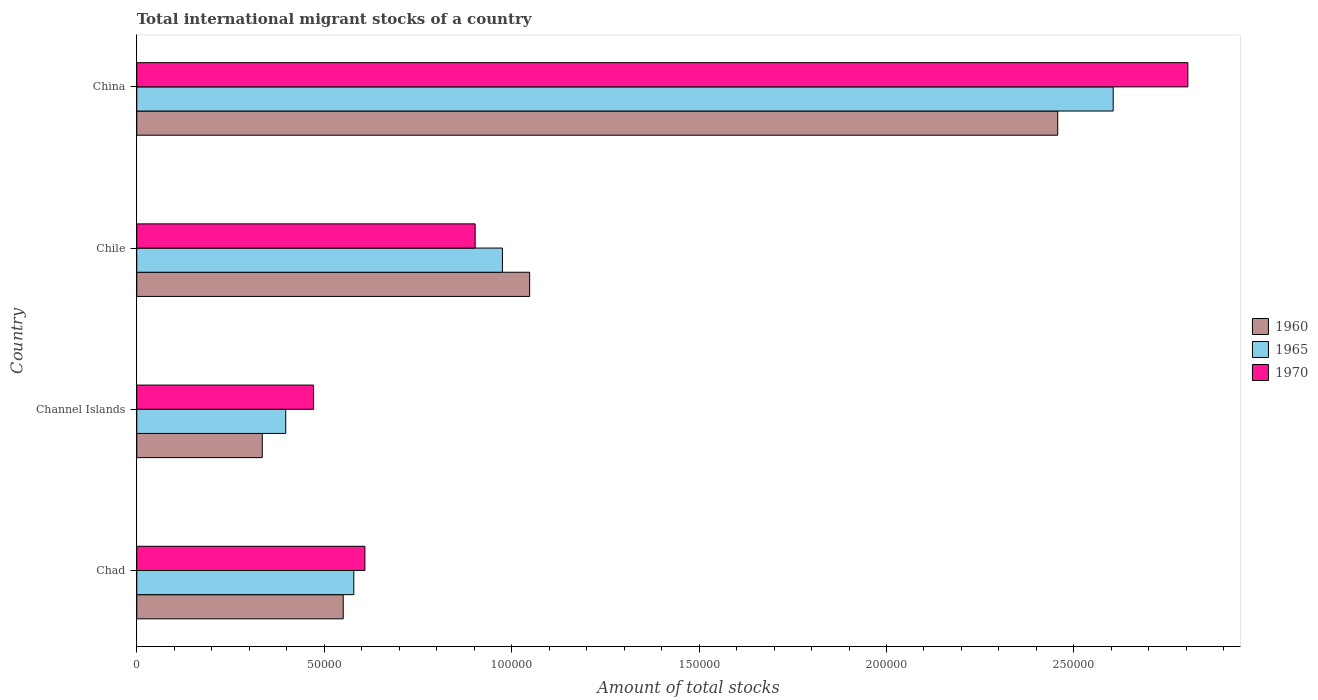How many different coloured bars are there?
Your response must be concise. 3. Are the number of bars per tick equal to the number of legend labels?
Your answer should be very brief. Yes. Are the number of bars on each tick of the Y-axis equal?
Your answer should be very brief. Yes. What is the amount of total stocks in in 1970 in Chad?
Offer a very short reply. 6.09e+04. Across all countries, what is the maximum amount of total stocks in in 1960?
Keep it short and to the point. 2.46e+05. Across all countries, what is the minimum amount of total stocks in in 1965?
Your answer should be compact. 3.97e+04. In which country was the amount of total stocks in in 1965 minimum?
Offer a very short reply. Channel Islands. What is the total amount of total stocks in in 1960 in the graph?
Your answer should be compact. 4.39e+05. What is the difference between the amount of total stocks in in 1960 in Chad and that in Channel Islands?
Provide a succinct answer. 2.16e+04. What is the difference between the amount of total stocks in in 1965 in China and the amount of total stocks in in 1970 in Chad?
Keep it short and to the point. 2.00e+05. What is the average amount of total stocks in in 1970 per country?
Offer a terse response. 1.20e+05. What is the difference between the amount of total stocks in in 1970 and amount of total stocks in in 1960 in China?
Your answer should be compact. 3.47e+04. What is the ratio of the amount of total stocks in in 1965 in Chad to that in Chile?
Provide a short and direct response. 0.59. Is the amount of total stocks in in 1960 in Channel Islands less than that in China?
Provide a succinct answer. Yes. What is the difference between the highest and the second highest amount of total stocks in in 1965?
Make the answer very short. 1.63e+05. What is the difference between the highest and the lowest amount of total stocks in in 1960?
Offer a very short reply. 2.12e+05. Is the sum of the amount of total stocks in in 1960 in Chad and Channel Islands greater than the maximum amount of total stocks in in 1970 across all countries?
Offer a very short reply. No. What does the 2nd bar from the top in China represents?
Your response must be concise. 1965. What does the 1st bar from the bottom in China represents?
Give a very brief answer. 1960. Is it the case that in every country, the sum of the amount of total stocks in in 1970 and amount of total stocks in in 1965 is greater than the amount of total stocks in in 1960?
Ensure brevity in your answer.  Yes. Are all the bars in the graph horizontal?
Your answer should be compact. Yes. How many countries are there in the graph?
Offer a very short reply. 4. What is the difference between two consecutive major ticks on the X-axis?
Offer a very short reply. 5.00e+04. Are the values on the major ticks of X-axis written in scientific E-notation?
Offer a very short reply. No. Does the graph contain any zero values?
Offer a very short reply. No. Does the graph contain grids?
Ensure brevity in your answer.  No. How many legend labels are there?
Provide a succinct answer. 3. How are the legend labels stacked?
Make the answer very short. Vertical. What is the title of the graph?
Provide a succinct answer. Total international migrant stocks of a country. What is the label or title of the X-axis?
Your answer should be compact. Amount of total stocks. What is the label or title of the Y-axis?
Offer a terse response. Country. What is the Amount of total stocks in 1960 in Chad?
Keep it short and to the point. 5.51e+04. What is the Amount of total stocks of 1965 in Chad?
Ensure brevity in your answer.  5.79e+04. What is the Amount of total stocks of 1970 in Chad?
Your response must be concise. 6.09e+04. What is the Amount of total stocks in 1960 in Channel Islands?
Provide a succinct answer. 3.35e+04. What is the Amount of total stocks in 1965 in Channel Islands?
Provide a short and direct response. 3.97e+04. What is the Amount of total stocks of 1970 in Channel Islands?
Provide a short and direct response. 4.72e+04. What is the Amount of total stocks of 1960 in Chile?
Provide a succinct answer. 1.05e+05. What is the Amount of total stocks of 1965 in Chile?
Your response must be concise. 9.76e+04. What is the Amount of total stocks of 1970 in Chile?
Your answer should be very brief. 9.03e+04. What is the Amount of total stocks of 1960 in China?
Ensure brevity in your answer.  2.46e+05. What is the Amount of total stocks of 1965 in China?
Provide a succinct answer. 2.60e+05. What is the Amount of total stocks of 1970 in China?
Offer a terse response. 2.80e+05. Across all countries, what is the maximum Amount of total stocks in 1960?
Provide a short and direct response. 2.46e+05. Across all countries, what is the maximum Amount of total stocks in 1965?
Provide a succinct answer. 2.60e+05. Across all countries, what is the maximum Amount of total stocks in 1970?
Provide a short and direct response. 2.80e+05. Across all countries, what is the minimum Amount of total stocks in 1960?
Provide a short and direct response. 3.35e+04. Across all countries, what is the minimum Amount of total stocks in 1965?
Keep it short and to the point. 3.97e+04. Across all countries, what is the minimum Amount of total stocks in 1970?
Keep it short and to the point. 4.72e+04. What is the total Amount of total stocks in 1960 in the graph?
Your answer should be compact. 4.39e+05. What is the total Amount of total stocks of 1965 in the graph?
Offer a terse response. 4.56e+05. What is the total Amount of total stocks in 1970 in the graph?
Your answer should be very brief. 4.79e+05. What is the difference between the Amount of total stocks in 1960 in Chad and that in Channel Islands?
Your answer should be compact. 2.16e+04. What is the difference between the Amount of total stocks of 1965 in Chad and that in Channel Islands?
Provide a succinct answer. 1.82e+04. What is the difference between the Amount of total stocks in 1970 in Chad and that in Channel Islands?
Your response must be concise. 1.37e+04. What is the difference between the Amount of total stocks in 1960 in Chad and that in Chile?
Provide a succinct answer. -4.97e+04. What is the difference between the Amount of total stocks of 1965 in Chad and that in Chile?
Give a very brief answer. -3.97e+04. What is the difference between the Amount of total stocks of 1970 in Chad and that in Chile?
Offer a very short reply. -2.94e+04. What is the difference between the Amount of total stocks of 1960 in Chad and that in China?
Give a very brief answer. -1.91e+05. What is the difference between the Amount of total stocks of 1965 in Chad and that in China?
Ensure brevity in your answer.  -2.03e+05. What is the difference between the Amount of total stocks in 1970 in Chad and that in China?
Your response must be concise. -2.20e+05. What is the difference between the Amount of total stocks of 1960 in Channel Islands and that in Chile?
Offer a terse response. -7.13e+04. What is the difference between the Amount of total stocks in 1965 in Channel Islands and that in Chile?
Your answer should be compact. -5.78e+04. What is the difference between the Amount of total stocks of 1970 in Channel Islands and that in Chile?
Keep it short and to the point. -4.31e+04. What is the difference between the Amount of total stocks in 1960 in Channel Islands and that in China?
Make the answer very short. -2.12e+05. What is the difference between the Amount of total stocks in 1965 in Channel Islands and that in China?
Ensure brevity in your answer.  -2.21e+05. What is the difference between the Amount of total stocks of 1970 in Channel Islands and that in China?
Offer a very short reply. -2.33e+05. What is the difference between the Amount of total stocks in 1960 in Chile and that in China?
Ensure brevity in your answer.  -1.41e+05. What is the difference between the Amount of total stocks in 1965 in Chile and that in China?
Provide a short and direct response. -1.63e+05. What is the difference between the Amount of total stocks in 1970 in Chile and that in China?
Give a very brief answer. -1.90e+05. What is the difference between the Amount of total stocks of 1960 in Chad and the Amount of total stocks of 1965 in Channel Islands?
Make the answer very short. 1.53e+04. What is the difference between the Amount of total stocks of 1960 in Chad and the Amount of total stocks of 1970 in Channel Islands?
Provide a short and direct response. 7907. What is the difference between the Amount of total stocks of 1965 in Chad and the Amount of total stocks of 1970 in Channel Islands?
Your answer should be compact. 1.07e+04. What is the difference between the Amount of total stocks in 1960 in Chad and the Amount of total stocks in 1965 in Chile?
Ensure brevity in your answer.  -4.25e+04. What is the difference between the Amount of total stocks in 1960 in Chad and the Amount of total stocks in 1970 in Chile?
Your answer should be compact. -3.52e+04. What is the difference between the Amount of total stocks in 1965 in Chad and the Amount of total stocks in 1970 in Chile?
Provide a succinct answer. -3.24e+04. What is the difference between the Amount of total stocks in 1960 in Chad and the Amount of total stocks in 1965 in China?
Your answer should be compact. -2.05e+05. What is the difference between the Amount of total stocks in 1960 in Chad and the Amount of total stocks in 1970 in China?
Your response must be concise. -2.25e+05. What is the difference between the Amount of total stocks in 1965 in Chad and the Amount of total stocks in 1970 in China?
Ensure brevity in your answer.  -2.23e+05. What is the difference between the Amount of total stocks in 1960 in Channel Islands and the Amount of total stocks in 1965 in Chile?
Your answer should be compact. -6.41e+04. What is the difference between the Amount of total stocks of 1960 in Channel Islands and the Amount of total stocks of 1970 in Chile?
Offer a very short reply. -5.68e+04. What is the difference between the Amount of total stocks of 1965 in Channel Islands and the Amount of total stocks of 1970 in Chile?
Your answer should be very brief. -5.05e+04. What is the difference between the Amount of total stocks in 1960 in Channel Islands and the Amount of total stocks in 1965 in China?
Offer a terse response. -2.27e+05. What is the difference between the Amount of total stocks in 1960 in Channel Islands and the Amount of total stocks in 1970 in China?
Give a very brief answer. -2.47e+05. What is the difference between the Amount of total stocks in 1965 in Channel Islands and the Amount of total stocks in 1970 in China?
Your answer should be compact. -2.41e+05. What is the difference between the Amount of total stocks of 1960 in Chile and the Amount of total stocks of 1965 in China?
Offer a terse response. -1.56e+05. What is the difference between the Amount of total stocks in 1960 in Chile and the Amount of total stocks in 1970 in China?
Offer a very short reply. -1.76e+05. What is the difference between the Amount of total stocks of 1965 in Chile and the Amount of total stocks of 1970 in China?
Give a very brief answer. -1.83e+05. What is the average Amount of total stocks of 1960 per country?
Your answer should be very brief. 1.10e+05. What is the average Amount of total stocks of 1965 per country?
Provide a succinct answer. 1.14e+05. What is the average Amount of total stocks in 1970 per country?
Your response must be concise. 1.20e+05. What is the difference between the Amount of total stocks in 1960 and Amount of total stocks in 1965 in Chad?
Your answer should be very brief. -2824. What is the difference between the Amount of total stocks of 1960 and Amount of total stocks of 1970 in Chad?
Your answer should be very brief. -5793. What is the difference between the Amount of total stocks in 1965 and Amount of total stocks in 1970 in Chad?
Give a very brief answer. -2969. What is the difference between the Amount of total stocks of 1960 and Amount of total stocks of 1965 in Channel Islands?
Your answer should be compact. -6257. What is the difference between the Amount of total stocks in 1960 and Amount of total stocks in 1970 in Channel Islands?
Make the answer very short. -1.37e+04. What is the difference between the Amount of total stocks in 1965 and Amount of total stocks in 1970 in Channel Islands?
Your response must be concise. -7426. What is the difference between the Amount of total stocks in 1960 and Amount of total stocks in 1965 in Chile?
Your answer should be very brief. 7254. What is the difference between the Amount of total stocks in 1960 and Amount of total stocks in 1970 in Chile?
Ensure brevity in your answer.  1.45e+04. What is the difference between the Amount of total stocks of 1965 and Amount of total stocks of 1970 in Chile?
Provide a succinct answer. 7280. What is the difference between the Amount of total stocks of 1960 and Amount of total stocks of 1965 in China?
Provide a short and direct response. -1.48e+04. What is the difference between the Amount of total stocks in 1960 and Amount of total stocks in 1970 in China?
Keep it short and to the point. -3.47e+04. What is the difference between the Amount of total stocks in 1965 and Amount of total stocks in 1970 in China?
Your answer should be very brief. -1.99e+04. What is the ratio of the Amount of total stocks of 1960 in Chad to that in Channel Islands?
Offer a terse response. 1.64. What is the ratio of the Amount of total stocks in 1965 in Chad to that in Channel Islands?
Offer a terse response. 1.46. What is the ratio of the Amount of total stocks of 1970 in Chad to that in Channel Islands?
Offer a very short reply. 1.29. What is the ratio of the Amount of total stocks in 1960 in Chad to that in Chile?
Give a very brief answer. 0.53. What is the ratio of the Amount of total stocks of 1965 in Chad to that in Chile?
Your response must be concise. 0.59. What is the ratio of the Amount of total stocks of 1970 in Chad to that in Chile?
Your response must be concise. 0.67. What is the ratio of the Amount of total stocks in 1960 in Chad to that in China?
Give a very brief answer. 0.22. What is the ratio of the Amount of total stocks in 1965 in Chad to that in China?
Your response must be concise. 0.22. What is the ratio of the Amount of total stocks in 1970 in Chad to that in China?
Your answer should be compact. 0.22. What is the ratio of the Amount of total stocks in 1960 in Channel Islands to that in Chile?
Keep it short and to the point. 0.32. What is the ratio of the Amount of total stocks in 1965 in Channel Islands to that in Chile?
Your response must be concise. 0.41. What is the ratio of the Amount of total stocks in 1970 in Channel Islands to that in Chile?
Your answer should be compact. 0.52. What is the ratio of the Amount of total stocks in 1960 in Channel Islands to that in China?
Provide a succinct answer. 0.14. What is the ratio of the Amount of total stocks in 1965 in Channel Islands to that in China?
Provide a succinct answer. 0.15. What is the ratio of the Amount of total stocks in 1970 in Channel Islands to that in China?
Give a very brief answer. 0.17. What is the ratio of the Amount of total stocks in 1960 in Chile to that in China?
Make the answer very short. 0.43. What is the ratio of the Amount of total stocks of 1965 in Chile to that in China?
Keep it short and to the point. 0.37. What is the ratio of the Amount of total stocks of 1970 in Chile to that in China?
Offer a terse response. 0.32. What is the difference between the highest and the second highest Amount of total stocks in 1960?
Make the answer very short. 1.41e+05. What is the difference between the highest and the second highest Amount of total stocks in 1965?
Your response must be concise. 1.63e+05. What is the difference between the highest and the second highest Amount of total stocks of 1970?
Make the answer very short. 1.90e+05. What is the difference between the highest and the lowest Amount of total stocks of 1960?
Provide a short and direct response. 2.12e+05. What is the difference between the highest and the lowest Amount of total stocks of 1965?
Provide a succinct answer. 2.21e+05. What is the difference between the highest and the lowest Amount of total stocks of 1970?
Provide a short and direct response. 2.33e+05. 